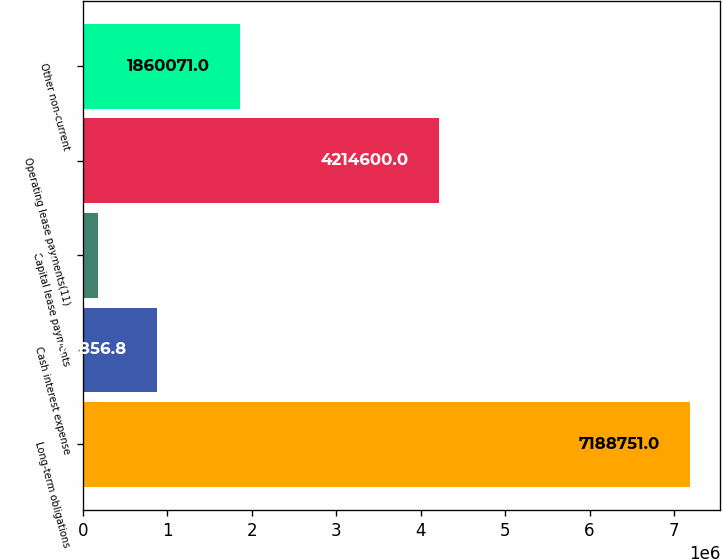Convert chart to OTSL. <chart><loc_0><loc_0><loc_500><loc_500><bar_chart><fcel>Long-term obligations<fcel>Cash interest expense<fcel>Capital lease payments<fcel>Operating lease payments(11)<fcel>Other non-current<nl><fcel>7.18875e+06<fcel>874857<fcel>173313<fcel>4.2146e+06<fcel>1.86007e+06<nl></chart> 